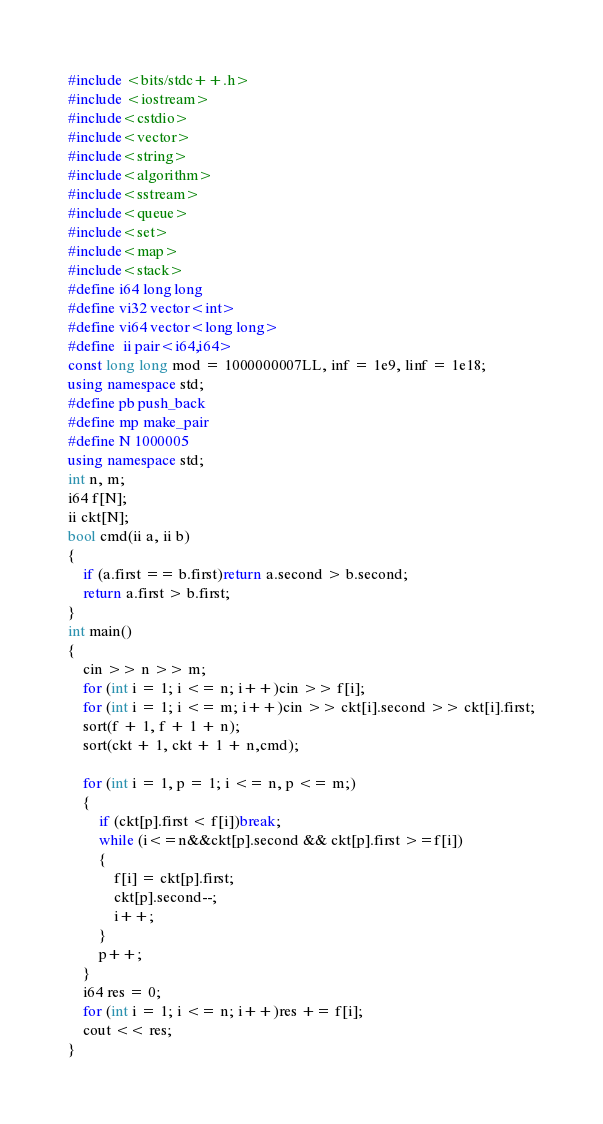<code> <loc_0><loc_0><loc_500><loc_500><_C++_>

#include <bits/stdc++.h>
#include <iostream>
#include<cstdio>
#include<vector>
#include<string>
#include<algorithm>
#include<sstream>
#include<queue>
#include<set>
#include<map>
#include<stack>
#define i64 long long
#define vi32 vector<int>
#define vi64 vector<long long>
#define  ii pair<i64,i64>
const long long mod = 1000000007LL, inf = 1e9, linf = 1e18;
using namespace std;
#define pb push_back
#define mp make_pair
#define N 1000005	
using namespace std;
int n, m;
i64 f[N];
ii ckt[N];
bool cmd(ii a, ii b)
{
	if (a.first == b.first)return a.second > b.second;
	return a.first > b.first;
}
int main()
{
	cin >> n >> m;
	for (int i = 1; i <= n; i++)cin >> f[i];
	for (int i = 1; i <= m; i++)cin >> ckt[i].second >> ckt[i].first;
	sort(f + 1, f + 1 + n);
	sort(ckt + 1, ckt + 1 + n,cmd);

	for (int i = 1, p = 1; i <= n, p <= m;)
	{
		if (ckt[p].first < f[i])break;
		while (i<=n&&ckt[p].second && ckt[p].first >=f[i])
		{
			f[i] = ckt[p].first;
			ckt[p].second--;
			i++;
		}
		p++;
	}
	i64 res = 0;
	for (int i = 1; i <= n; i++)res += f[i];
	cout << res;
}

</code> 